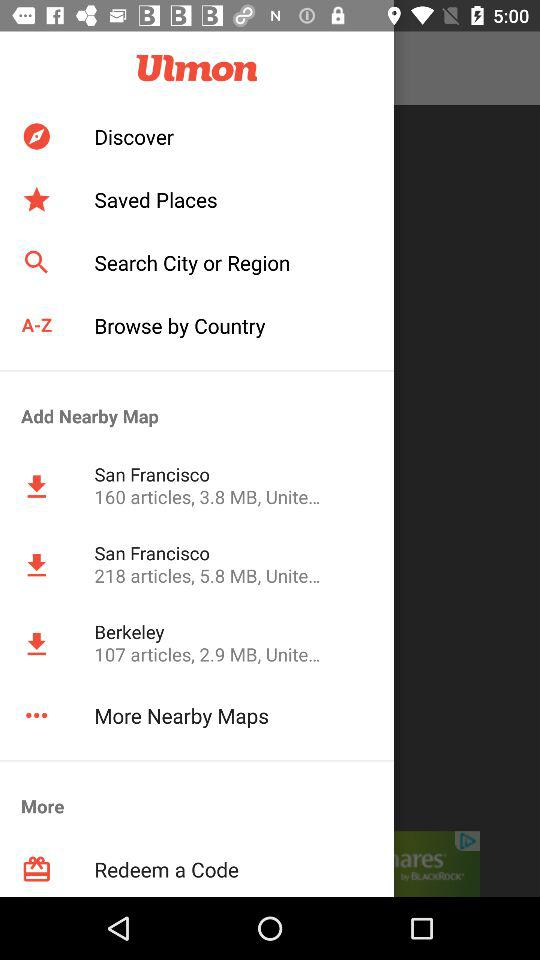How many articles are there on Berkeley? There are 107 articles on Berkeley. 